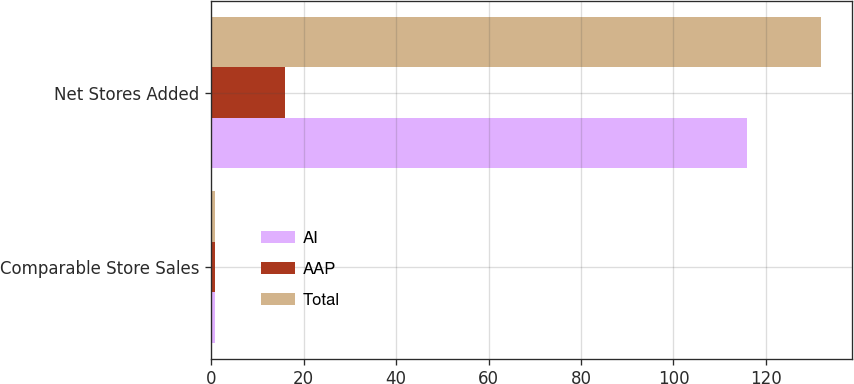Convert chart to OTSL. <chart><loc_0><loc_0><loc_500><loc_500><stacked_bar_chart><ecel><fcel>Comparable Store Sales<fcel>Net Stores Added<nl><fcel>AI<fcel>0.9<fcel>116<nl><fcel>AAP<fcel>0.8<fcel>16<nl><fcel>Total<fcel>0.8<fcel>132<nl></chart> 